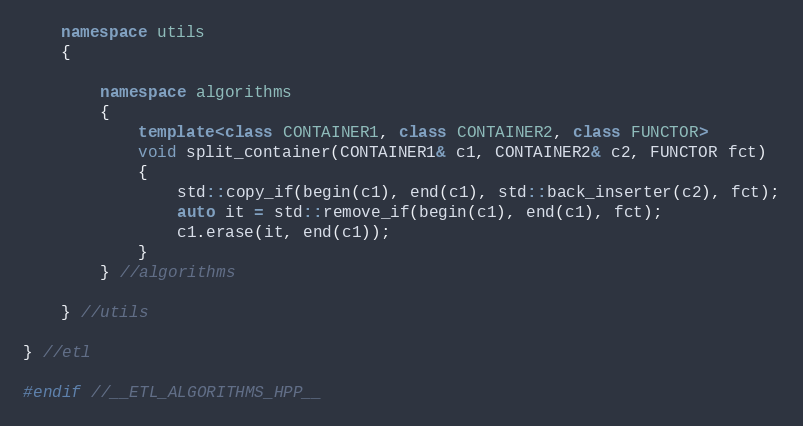Convert code to text. <code><loc_0><loc_0><loc_500><loc_500><_C++_>	namespace utils
	{
	
		namespace algorithms
		{
			template<class CONTAINER1, class CONTAINER2, class FUNCTOR>
			void split_container(CONTAINER1& c1, CONTAINER2& c2, FUNCTOR fct)
			{
				std::copy_if(begin(c1), end(c1), std::back_inserter(c2), fct);
				auto it = std::remove_if(begin(c1), end(c1), fct);
				c1.erase(it, end(c1));
			}
		} //algorithms
		
	} //utils
	
} //etl

#endif //__ETL_ALGORITHMS_HPP__</code> 